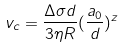Convert formula to latex. <formula><loc_0><loc_0><loc_500><loc_500>v _ { c } = \frac { \Delta \sigma d } { 3 \eta R } ( \frac { a _ { 0 } } { d } ) ^ { z }</formula> 